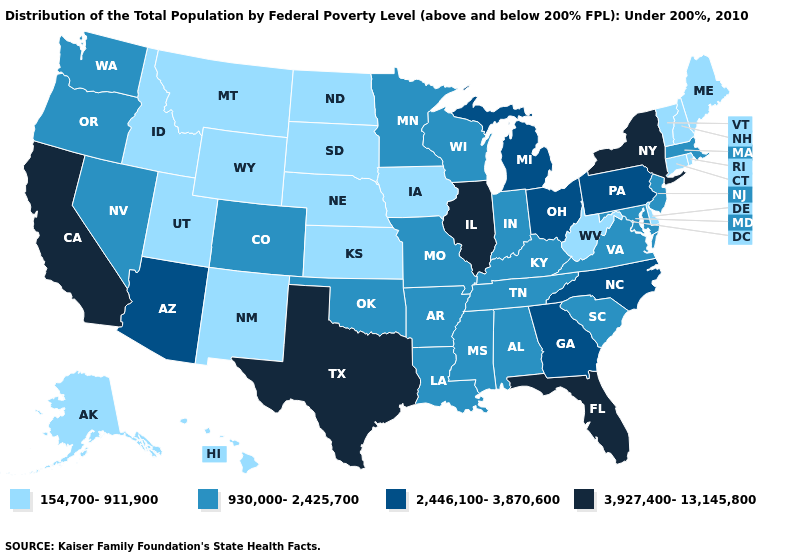What is the value of Kansas?
Answer briefly. 154,700-911,900. Name the states that have a value in the range 930,000-2,425,700?
Answer briefly. Alabama, Arkansas, Colorado, Indiana, Kentucky, Louisiana, Maryland, Massachusetts, Minnesota, Mississippi, Missouri, Nevada, New Jersey, Oklahoma, Oregon, South Carolina, Tennessee, Virginia, Washington, Wisconsin. What is the highest value in the USA?
Write a very short answer. 3,927,400-13,145,800. Name the states that have a value in the range 154,700-911,900?
Be succinct. Alaska, Connecticut, Delaware, Hawaii, Idaho, Iowa, Kansas, Maine, Montana, Nebraska, New Hampshire, New Mexico, North Dakota, Rhode Island, South Dakota, Utah, Vermont, West Virginia, Wyoming. How many symbols are there in the legend?
Answer briefly. 4. What is the value of Idaho?
Short answer required. 154,700-911,900. Among the states that border Nebraska , which have the highest value?
Concise answer only. Colorado, Missouri. Name the states that have a value in the range 3,927,400-13,145,800?
Give a very brief answer. California, Florida, Illinois, New York, Texas. How many symbols are there in the legend?
Keep it brief. 4. What is the highest value in states that border Utah?
Be succinct. 2,446,100-3,870,600. What is the value of Nevada?
Concise answer only. 930,000-2,425,700. What is the lowest value in the USA?
Be succinct. 154,700-911,900. Which states have the lowest value in the USA?
Give a very brief answer. Alaska, Connecticut, Delaware, Hawaii, Idaho, Iowa, Kansas, Maine, Montana, Nebraska, New Hampshire, New Mexico, North Dakota, Rhode Island, South Dakota, Utah, Vermont, West Virginia, Wyoming. Name the states that have a value in the range 3,927,400-13,145,800?
Quick response, please. California, Florida, Illinois, New York, Texas. Name the states that have a value in the range 2,446,100-3,870,600?
Write a very short answer. Arizona, Georgia, Michigan, North Carolina, Ohio, Pennsylvania. 